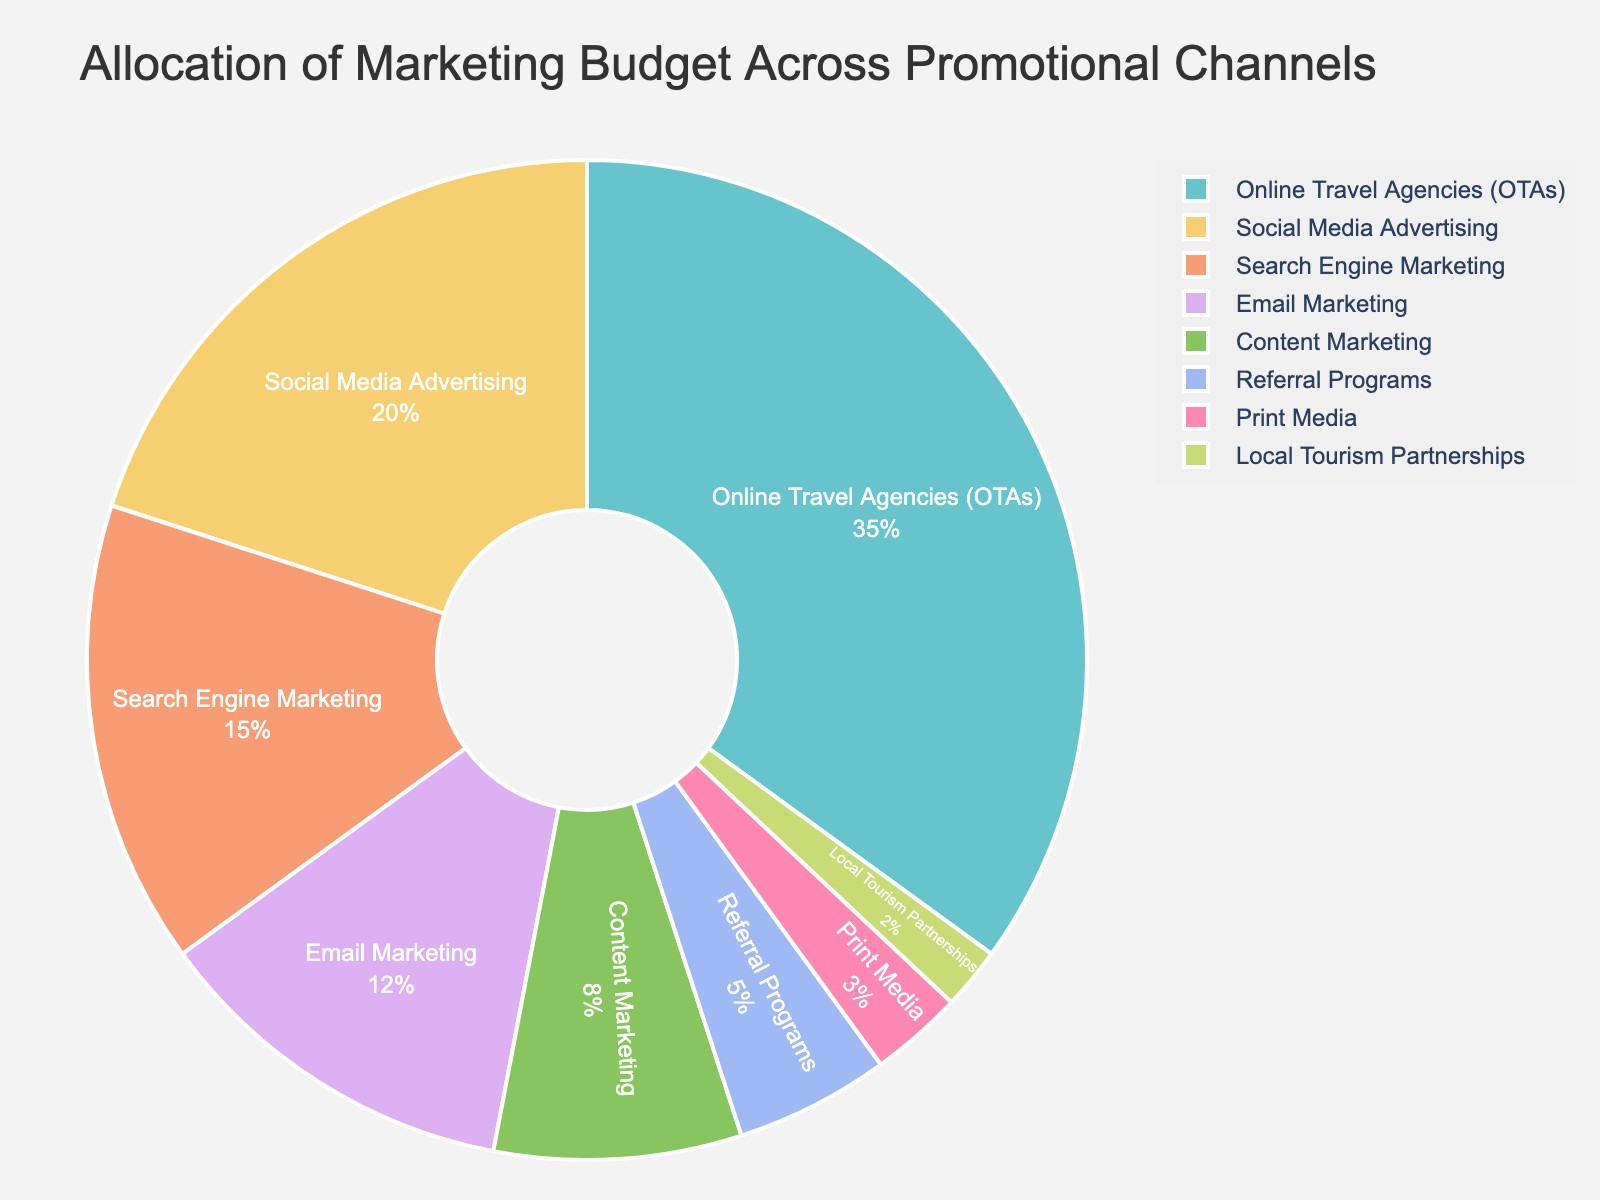what is the highest allocated promotional channel? The largest segment in the pie chart, labeled "Online Travel Agencies (OTAs)", represents the highest allocated promotional channel with 35%.
Answer: Online Travel Agencies (OTAs) Which two channels combined have the same budget allocation as Online Travel Agencies (OTAs)? The "Online Travel Agencies (OTAs)" segment is 35%. The two channels "Social Media Advertising" (20%) and "Search Engine Marketing" (15%) together add up to 35%, which is equal to the allocation of Online Travel Agencies (OTAs).
Answer: Social Media Advertising and Search Engine Marketing Is the percentage allocated to Email Marketing greater than that of Referral Programs and Print Media combined? The segment for Email Marketing has 12%. The combined allocation of Referral Programs (5%) and Print Media (3%) is 8%. Thus, Email Marketing's allocation (12%) is greater.
Answer: Yes What is the total percentage allocated to the channels below 10% individually? The channels below 10% are Content Marketing (8%), Referral Programs (5%), Print Media (3%), and Local Tourism Partnerships (2%). Summing these gives 8% + 5% + 3% + 2% = 18%.
Answer: 18% What is the difference in budget allocation between the highest and lowest allocated channels? The highest allocated channel is Online Travel Agencies (OTAs) at 35%, and the lowest is Local Tourism Partnerships at 2%. The difference is 35% - 2% = 33%.
Answer: 33% Which promotional channels are allocated more than 10% but less than 20%? The channels that fit this criterion are: "Social Media Advertising" with 20% and "Search Engine Marketing" with 15%.
Answer: Social Media Advertising and Search Engine Marketing In terms of budget allocation, which is larger: the allocation for Social Media Advertising or the combined allocations for Email Marketing and Content Marketing? Social Media Advertising is allocated 20%. The combined allocation for Email Marketing (12%) and Content Marketing (8%) is 12% + 8% = 20%. They are equal in terms of budget allocation.
Answer: They are equal Does the segment representing Print Media appear to be significantly larger or smaller than the segment representing Referral Programs, and by how much? Print Media is allocated 3%, while Referral Programs are allocated 5%. The difference is 5% - 3% = 2%, so Print Media is smaller by 2%.
Answer: Smaller by 2% What percentage of the marketing budget is allocated to digital forms of marketing? Digital marketing channels include Online Travel Agencies (35%), Social Media Advertising (20%), Search Engine Marketing (15%), Email Marketing (12%), and Content Marketing (8%). Summing these gives 35% + 20% + 15% + 12% + 8% = 90%.
Answer: 90% Would you say the marketing budget is predominantly digital or traditional? Given that 90% of the budget is allocated to digital channels (Online Travel Agencies, Social Media Advertising, Search Engine Marketing, Email Marketing, and Content Marketing), it indicates a predominantly digital marketing budget.
Answer: Digital 